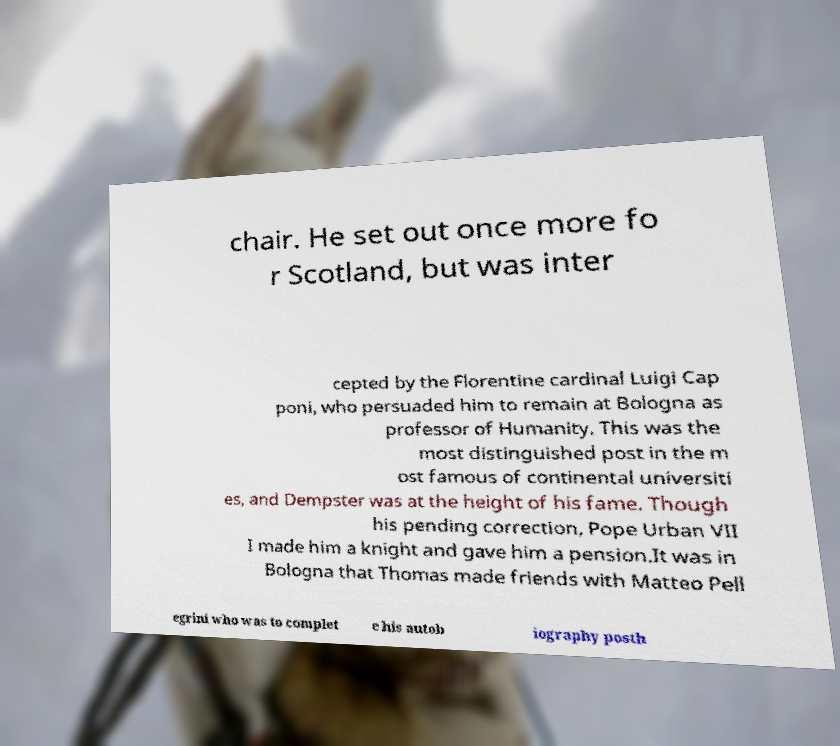There's text embedded in this image that I need extracted. Can you transcribe it verbatim? chair. He set out once more fo r Scotland, but was inter cepted by the Florentine cardinal Luigi Cap poni, who persuaded him to remain at Bologna as professor of Humanity. This was the most distinguished post in the m ost famous of continental universiti es, and Dempster was at the height of his fame. Though his pending correction, Pope Urban VII I made him a knight and gave him a pension.It was in Bologna that Thomas made friends with Matteo Pell egrini who was to complet e his autob iography posth 